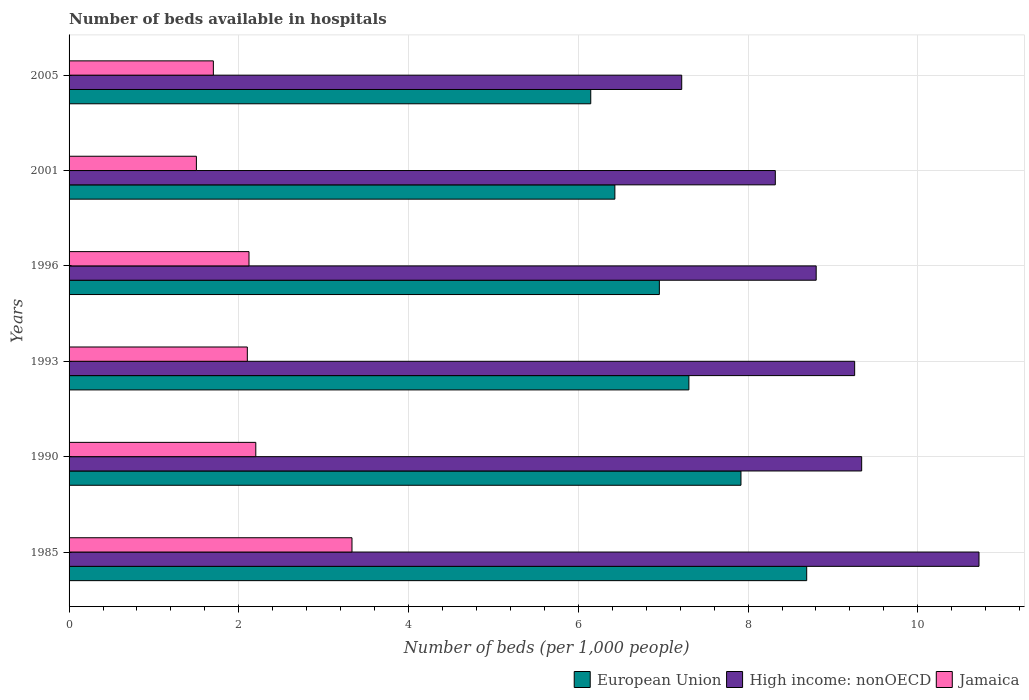Are the number of bars per tick equal to the number of legend labels?
Your answer should be compact. Yes. How many bars are there on the 4th tick from the bottom?
Your response must be concise. 3. What is the label of the 6th group of bars from the top?
Your answer should be very brief. 1985. In how many cases, is the number of bars for a given year not equal to the number of legend labels?
Provide a succinct answer. 0. What is the number of beds in the hospiatls of in European Union in 2005?
Your answer should be compact. 6.15. Across all years, what is the maximum number of beds in the hospiatls of in High income: nonOECD?
Your response must be concise. 10.72. Across all years, what is the minimum number of beds in the hospiatls of in European Union?
Offer a very short reply. 6.15. In which year was the number of beds in the hospiatls of in European Union maximum?
Your answer should be compact. 1985. What is the total number of beds in the hospiatls of in High income: nonOECD in the graph?
Make the answer very short. 53.66. What is the difference between the number of beds in the hospiatls of in Jamaica in 2001 and that in 2005?
Provide a succinct answer. -0.2. What is the difference between the number of beds in the hospiatls of in European Union in 1990 and the number of beds in the hospiatls of in High income: nonOECD in 1996?
Provide a succinct answer. -0.89. What is the average number of beds in the hospiatls of in High income: nonOECD per year?
Keep it short and to the point. 8.94. In the year 1990, what is the difference between the number of beds in the hospiatls of in High income: nonOECD and number of beds in the hospiatls of in Jamaica?
Make the answer very short. 7.14. What is the ratio of the number of beds in the hospiatls of in European Union in 1990 to that in 1996?
Your answer should be very brief. 1.14. Is the difference between the number of beds in the hospiatls of in High income: nonOECD in 1990 and 1993 greater than the difference between the number of beds in the hospiatls of in Jamaica in 1990 and 1993?
Offer a very short reply. No. What is the difference between the highest and the second highest number of beds in the hospiatls of in European Union?
Offer a terse response. 0.77. What is the difference between the highest and the lowest number of beds in the hospiatls of in Jamaica?
Make the answer very short. 1.83. In how many years, is the number of beds in the hospiatls of in Jamaica greater than the average number of beds in the hospiatls of in Jamaica taken over all years?
Your answer should be compact. 2. Is the sum of the number of beds in the hospiatls of in Jamaica in 1996 and 2001 greater than the maximum number of beds in the hospiatls of in European Union across all years?
Your answer should be compact. No. What does the 1st bar from the top in 2001 represents?
Your answer should be compact. Jamaica. What does the 2nd bar from the bottom in 1990 represents?
Offer a terse response. High income: nonOECD. Is it the case that in every year, the sum of the number of beds in the hospiatls of in European Union and number of beds in the hospiatls of in Jamaica is greater than the number of beds in the hospiatls of in High income: nonOECD?
Provide a short and direct response. No. How many years are there in the graph?
Offer a very short reply. 6. What is the difference between two consecutive major ticks on the X-axis?
Ensure brevity in your answer.  2. Does the graph contain any zero values?
Your answer should be very brief. No. Where does the legend appear in the graph?
Your answer should be very brief. Bottom right. How many legend labels are there?
Offer a very short reply. 3. What is the title of the graph?
Offer a terse response. Number of beds available in hospitals. Does "Slovak Republic" appear as one of the legend labels in the graph?
Your answer should be very brief. No. What is the label or title of the X-axis?
Provide a short and direct response. Number of beds (per 1,0 people). What is the Number of beds (per 1,000 people) of European Union in 1985?
Give a very brief answer. 8.69. What is the Number of beds (per 1,000 people) of High income: nonOECD in 1985?
Provide a succinct answer. 10.72. What is the Number of beds (per 1,000 people) in Jamaica in 1985?
Make the answer very short. 3.33. What is the Number of beds (per 1,000 people) in European Union in 1990?
Provide a short and direct response. 7.92. What is the Number of beds (per 1,000 people) in High income: nonOECD in 1990?
Provide a short and direct response. 9.34. What is the Number of beds (per 1,000 people) of Jamaica in 1990?
Ensure brevity in your answer.  2.2. What is the Number of beds (per 1,000 people) of European Union in 1993?
Provide a short and direct response. 7.3. What is the Number of beds (per 1,000 people) in High income: nonOECD in 1993?
Your answer should be very brief. 9.26. What is the Number of beds (per 1,000 people) in Jamaica in 1993?
Your answer should be very brief. 2.1. What is the Number of beds (per 1,000 people) of European Union in 1996?
Keep it short and to the point. 6.95. What is the Number of beds (per 1,000 people) in High income: nonOECD in 1996?
Offer a terse response. 8.8. What is the Number of beds (per 1,000 people) of Jamaica in 1996?
Make the answer very short. 2.12. What is the Number of beds (per 1,000 people) of European Union in 2001?
Provide a short and direct response. 6.43. What is the Number of beds (per 1,000 people) of High income: nonOECD in 2001?
Provide a short and direct response. 8.32. What is the Number of beds (per 1,000 people) in European Union in 2005?
Provide a short and direct response. 6.15. What is the Number of beds (per 1,000 people) of High income: nonOECD in 2005?
Make the answer very short. 7.22. What is the Number of beds (per 1,000 people) in Jamaica in 2005?
Provide a succinct answer. 1.7. Across all years, what is the maximum Number of beds (per 1,000 people) of European Union?
Give a very brief answer. 8.69. Across all years, what is the maximum Number of beds (per 1,000 people) in High income: nonOECD?
Your answer should be very brief. 10.72. Across all years, what is the maximum Number of beds (per 1,000 people) of Jamaica?
Provide a short and direct response. 3.33. Across all years, what is the minimum Number of beds (per 1,000 people) of European Union?
Your response must be concise. 6.15. Across all years, what is the minimum Number of beds (per 1,000 people) of High income: nonOECD?
Your response must be concise. 7.22. Across all years, what is the minimum Number of beds (per 1,000 people) of Jamaica?
Provide a short and direct response. 1.5. What is the total Number of beds (per 1,000 people) of European Union in the graph?
Ensure brevity in your answer.  43.44. What is the total Number of beds (per 1,000 people) in High income: nonOECD in the graph?
Offer a terse response. 53.66. What is the total Number of beds (per 1,000 people) of Jamaica in the graph?
Provide a succinct answer. 12.95. What is the difference between the Number of beds (per 1,000 people) in European Union in 1985 and that in 1990?
Your response must be concise. 0.77. What is the difference between the Number of beds (per 1,000 people) in High income: nonOECD in 1985 and that in 1990?
Your answer should be compact. 1.38. What is the difference between the Number of beds (per 1,000 people) in Jamaica in 1985 and that in 1990?
Offer a terse response. 1.13. What is the difference between the Number of beds (per 1,000 people) of European Union in 1985 and that in 1993?
Keep it short and to the point. 1.39. What is the difference between the Number of beds (per 1,000 people) of High income: nonOECD in 1985 and that in 1993?
Provide a short and direct response. 1.47. What is the difference between the Number of beds (per 1,000 people) of Jamaica in 1985 and that in 1993?
Provide a succinct answer. 1.23. What is the difference between the Number of beds (per 1,000 people) of European Union in 1985 and that in 1996?
Offer a terse response. 1.74. What is the difference between the Number of beds (per 1,000 people) in High income: nonOECD in 1985 and that in 1996?
Your answer should be very brief. 1.92. What is the difference between the Number of beds (per 1,000 people) of Jamaica in 1985 and that in 1996?
Your answer should be very brief. 1.21. What is the difference between the Number of beds (per 1,000 people) in European Union in 1985 and that in 2001?
Make the answer very short. 2.26. What is the difference between the Number of beds (per 1,000 people) of High income: nonOECD in 1985 and that in 2001?
Your answer should be very brief. 2.4. What is the difference between the Number of beds (per 1,000 people) of Jamaica in 1985 and that in 2001?
Your response must be concise. 1.83. What is the difference between the Number of beds (per 1,000 people) in European Union in 1985 and that in 2005?
Your answer should be compact. 2.54. What is the difference between the Number of beds (per 1,000 people) in High income: nonOECD in 1985 and that in 2005?
Your answer should be very brief. 3.5. What is the difference between the Number of beds (per 1,000 people) of Jamaica in 1985 and that in 2005?
Provide a short and direct response. 1.63. What is the difference between the Number of beds (per 1,000 people) of European Union in 1990 and that in 1993?
Provide a succinct answer. 0.61. What is the difference between the Number of beds (per 1,000 people) in High income: nonOECD in 1990 and that in 1993?
Provide a short and direct response. 0.08. What is the difference between the Number of beds (per 1,000 people) in Jamaica in 1990 and that in 1993?
Provide a short and direct response. 0.1. What is the difference between the Number of beds (per 1,000 people) in European Union in 1990 and that in 1996?
Give a very brief answer. 0.96. What is the difference between the Number of beds (per 1,000 people) in High income: nonOECD in 1990 and that in 1996?
Your response must be concise. 0.54. What is the difference between the Number of beds (per 1,000 people) in Jamaica in 1990 and that in 1996?
Offer a terse response. 0.08. What is the difference between the Number of beds (per 1,000 people) of European Union in 1990 and that in 2001?
Ensure brevity in your answer.  1.49. What is the difference between the Number of beds (per 1,000 people) of High income: nonOECD in 1990 and that in 2001?
Ensure brevity in your answer.  1.02. What is the difference between the Number of beds (per 1,000 people) in Jamaica in 1990 and that in 2001?
Offer a terse response. 0.7. What is the difference between the Number of beds (per 1,000 people) of European Union in 1990 and that in 2005?
Give a very brief answer. 1.77. What is the difference between the Number of beds (per 1,000 people) of High income: nonOECD in 1990 and that in 2005?
Ensure brevity in your answer.  2.12. What is the difference between the Number of beds (per 1,000 people) of European Union in 1993 and that in 1996?
Provide a succinct answer. 0.35. What is the difference between the Number of beds (per 1,000 people) in High income: nonOECD in 1993 and that in 1996?
Provide a short and direct response. 0.45. What is the difference between the Number of beds (per 1,000 people) in Jamaica in 1993 and that in 1996?
Your answer should be very brief. -0.02. What is the difference between the Number of beds (per 1,000 people) in European Union in 1993 and that in 2001?
Offer a very short reply. 0.87. What is the difference between the Number of beds (per 1,000 people) of High income: nonOECD in 1993 and that in 2001?
Give a very brief answer. 0.93. What is the difference between the Number of beds (per 1,000 people) of Jamaica in 1993 and that in 2001?
Offer a terse response. 0.6. What is the difference between the Number of beds (per 1,000 people) of European Union in 1993 and that in 2005?
Provide a short and direct response. 1.16. What is the difference between the Number of beds (per 1,000 people) of High income: nonOECD in 1993 and that in 2005?
Your response must be concise. 2.04. What is the difference between the Number of beds (per 1,000 people) in Jamaica in 1993 and that in 2005?
Offer a very short reply. 0.4. What is the difference between the Number of beds (per 1,000 people) of European Union in 1996 and that in 2001?
Offer a very short reply. 0.52. What is the difference between the Number of beds (per 1,000 people) of High income: nonOECD in 1996 and that in 2001?
Offer a very short reply. 0.48. What is the difference between the Number of beds (per 1,000 people) in Jamaica in 1996 and that in 2001?
Provide a succinct answer. 0.62. What is the difference between the Number of beds (per 1,000 people) in European Union in 1996 and that in 2005?
Offer a very short reply. 0.81. What is the difference between the Number of beds (per 1,000 people) in High income: nonOECD in 1996 and that in 2005?
Give a very brief answer. 1.58. What is the difference between the Number of beds (per 1,000 people) in Jamaica in 1996 and that in 2005?
Offer a terse response. 0.42. What is the difference between the Number of beds (per 1,000 people) of European Union in 2001 and that in 2005?
Provide a succinct answer. 0.28. What is the difference between the Number of beds (per 1,000 people) in High income: nonOECD in 2001 and that in 2005?
Give a very brief answer. 1.1. What is the difference between the Number of beds (per 1,000 people) of Jamaica in 2001 and that in 2005?
Offer a very short reply. -0.2. What is the difference between the Number of beds (per 1,000 people) of European Union in 1985 and the Number of beds (per 1,000 people) of High income: nonOECD in 1990?
Your response must be concise. -0.65. What is the difference between the Number of beds (per 1,000 people) of European Union in 1985 and the Number of beds (per 1,000 people) of Jamaica in 1990?
Provide a short and direct response. 6.49. What is the difference between the Number of beds (per 1,000 people) in High income: nonOECD in 1985 and the Number of beds (per 1,000 people) in Jamaica in 1990?
Keep it short and to the point. 8.52. What is the difference between the Number of beds (per 1,000 people) in European Union in 1985 and the Number of beds (per 1,000 people) in High income: nonOECD in 1993?
Keep it short and to the point. -0.56. What is the difference between the Number of beds (per 1,000 people) in European Union in 1985 and the Number of beds (per 1,000 people) in Jamaica in 1993?
Your answer should be compact. 6.59. What is the difference between the Number of beds (per 1,000 people) in High income: nonOECD in 1985 and the Number of beds (per 1,000 people) in Jamaica in 1993?
Your answer should be compact. 8.62. What is the difference between the Number of beds (per 1,000 people) in European Union in 1985 and the Number of beds (per 1,000 people) in High income: nonOECD in 1996?
Keep it short and to the point. -0.11. What is the difference between the Number of beds (per 1,000 people) of European Union in 1985 and the Number of beds (per 1,000 people) of Jamaica in 1996?
Offer a terse response. 6.57. What is the difference between the Number of beds (per 1,000 people) in High income: nonOECD in 1985 and the Number of beds (per 1,000 people) in Jamaica in 1996?
Offer a terse response. 8.6. What is the difference between the Number of beds (per 1,000 people) in European Union in 1985 and the Number of beds (per 1,000 people) in High income: nonOECD in 2001?
Your response must be concise. 0.37. What is the difference between the Number of beds (per 1,000 people) in European Union in 1985 and the Number of beds (per 1,000 people) in Jamaica in 2001?
Make the answer very short. 7.19. What is the difference between the Number of beds (per 1,000 people) of High income: nonOECD in 1985 and the Number of beds (per 1,000 people) of Jamaica in 2001?
Give a very brief answer. 9.22. What is the difference between the Number of beds (per 1,000 people) of European Union in 1985 and the Number of beds (per 1,000 people) of High income: nonOECD in 2005?
Give a very brief answer. 1.47. What is the difference between the Number of beds (per 1,000 people) in European Union in 1985 and the Number of beds (per 1,000 people) in Jamaica in 2005?
Make the answer very short. 6.99. What is the difference between the Number of beds (per 1,000 people) of High income: nonOECD in 1985 and the Number of beds (per 1,000 people) of Jamaica in 2005?
Your answer should be compact. 9.02. What is the difference between the Number of beds (per 1,000 people) in European Union in 1990 and the Number of beds (per 1,000 people) in High income: nonOECD in 1993?
Provide a short and direct response. -1.34. What is the difference between the Number of beds (per 1,000 people) of European Union in 1990 and the Number of beds (per 1,000 people) of Jamaica in 1993?
Your answer should be compact. 5.82. What is the difference between the Number of beds (per 1,000 people) of High income: nonOECD in 1990 and the Number of beds (per 1,000 people) of Jamaica in 1993?
Offer a terse response. 7.24. What is the difference between the Number of beds (per 1,000 people) in European Union in 1990 and the Number of beds (per 1,000 people) in High income: nonOECD in 1996?
Offer a very short reply. -0.89. What is the difference between the Number of beds (per 1,000 people) of European Union in 1990 and the Number of beds (per 1,000 people) of Jamaica in 1996?
Your answer should be compact. 5.8. What is the difference between the Number of beds (per 1,000 people) in High income: nonOECD in 1990 and the Number of beds (per 1,000 people) in Jamaica in 1996?
Give a very brief answer. 7.22. What is the difference between the Number of beds (per 1,000 people) in European Union in 1990 and the Number of beds (per 1,000 people) in High income: nonOECD in 2001?
Your answer should be very brief. -0.4. What is the difference between the Number of beds (per 1,000 people) of European Union in 1990 and the Number of beds (per 1,000 people) of Jamaica in 2001?
Provide a succinct answer. 6.42. What is the difference between the Number of beds (per 1,000 people) of High income: nonOECD in 1990 and the Number of beds (per 1,000 people) of Jamaica in 2001?
Give a very brief answer. 7.84. What is the difference between the Number of beds (per 1,000 people) of European Union in 1990 and the Number of beds (per 1,000 people) of High income: nonOECD in 2005?
Offer a terse response. 0.7. What is the difference between the Number of beds (per 1,000 people) in European Union in 1990 and the Number of beds (per 1,000 people) in Jamaica in 2005?
Ensure brevity in your answer.  6.22. What is the difference between the Number of beds (per 1,000 people) in High income: nonOECD in 1990 and the Number of beds (per 1,000 people) in Jamaica in 2005?
Provide a succinct answer. 7.64. What is the difference between the Number of beds (per 1,000 people) of European Union in 1993 and the Number of beds (per 1,000 people) of High income: nonOECD in 1996?
Your answer should be very brief. -1.5. What is the difference between the Number of beds (per 1,000 people) of European Union in 1993 and the Number of beds (per 1,000 people) of Jamaica in 1996?
Offer a very short reply. 5.18. What is the difference between the Number of beds (per 1,000 people) in High income: nonOECD in 1993 and the Number of beds (per 1,000 people) in Jamaica in 1996?
Keep it short and to the point. 7.14. What is the difference between the Number of beds (per 1,000 people) of European Union in 1993 and the Number of beds (per 1,000 people) of High income: nonOECD in 2001?
Your response must be concise. -1.02. What is the difference between the Number of beds (per 1,000 people) of European Union in 1993 and the Number of beds (per 1,000 people) of Jamaica in 2001?
Your response must be concise. 5.8. What is the difference between the Number of beds (per 1,000 people) in High income: nonOECD in 1993 and the Number of beds (per 1,000 people) in Jamaica in 2001?
Your response must be concise. 7.76. What is the difference between the Number of beds (per 1,000 people) of European Union in 1993 and the Number of beds (per 1,000 people) of High income: nonOECD in 2005?
Your answer should be very brief. 0.08. What is the difference between the Number of beds (per 1,000 people) in European Union in 1993 and the Number of beds (per 1,000 people) in Jamaica in 2005?
Give a very brief answer. 5.6. What is the difference between the Number of beds (per 1,000 people) in High income: nonOECD in 1993 and the Number of beds (per 1,000 people) in Jamaica in 2005?
Offer a very short reply. 7.56. What is the difference between the Number of beds (per 1,000 people) of European Union in 1996 and the Number of beds (per 1,000 people) of High income: nonOECD in 2001?
Make the answer very short. -1.37. What is the difference between the Number of beds (per 1,000 people) in European Union in 1996 and the Number of beds (per 1,000 people) in Jamaica in 2001?
Give a very brief answer. 5.45. What is the difference between the Number of beds (per 1,000 people) of High income: nonOECD in 1996 and the Number of beds (per 1,000 people) of Jamaica in 2001?
Ensure brevity in your answer.  7.3. What is the difference between the Number of beds (per 1,000 people) of European Union in 1996 and the Number of beds (per 1,000 people) of High income: nonOECD in 2005?
Ensure brevity in your answer.  -0.26. What is the difference between the Number of beds (per 1,000 people) of European Union in 1996 and the Number of beds (per 1,000 people) of Jamaica in 2005?
Your response must be concise. 5.25. What is the difference between the Number of beds (per 1,000 people) in High income: nonOECD in 1996 and the Number of beds (per 1,000 people) in Jamaica in 2005?
Offer a terse response. 7.1. What is the difference between the Number of beds (per 1,000 people) of European Union in 2001 and the Number of beds (per 1,000 people) of High income: nonOECD in 2005?
Your response must be concise. -0.79. What is the difference between the Number of beds (per 1,000 people) of European Union in 2001 and the Number of beds (per 1,000 people) of Jamaica in 2005?
Make the answer very short. 4.73. What is the difference between the Number of beds (per 1,000 people) of High income: nonOECD in 2001 and the Number of beds (per 1,000 people) of Jamaica in 2005?
Provide a succinct answer. 6.62. What is the average Number of beds (per 1,000 people) in European Union per year?
Offer a very short reply. 7.24. What is the average Number of beds (per 1,000 people) in High income: nonOECD per year?
Provide a succinct answer. 8.94. What is the average Number of beds (per 1,000 people) of Jamaica per year?
Offer a very short reply. 2.16. In the year 1985, what is the difference between the Number of beds (per 1,000 people) in European Union and Number of beds (per 1,000 people) in High income: nonOECD?
Ensure brevity in your answer.  -2.03. In the year 1985, what is the difference between the Number of beds (per 1,000 people) of European Union and Number of beds (per 1,000 people) of Jamaica?
Offer a very short reply. 5.36. In the year 1985, what is the difference between the Number of beds (per 1,000 people) of High income: nonOECD and Number of beds (per 1,000 people) of Jamaica?
Make the answer very short. 7.39. In the year 1990, what is the difference between the Number of beds (per 1,000 people) of European Union and Number of beds (per 1,000 people) of High income: nonOECD?
Keep it short and to the point. -1.42. In the year 1990, what is the difference between the Number of beds (per 1,000 people) in European Union and Number of beds (per 1,000 people) in Jamaica?
Offer a terse response. 5.72. In the year 1990, what is the difference between the Number of beds (per 1,000 people) of High income: nonOECD and Number of beds (per 1,000 people) of Jamaica?
Ensure brevity in your answer.  7.14. In the year 1993, what is the difference between the Number of beds (per 1,000 people) in European Union and Number of beds (per 1,000 people) in High income: nonOECD?
Your answer should be compact. -1.95. In the year 1993, what is the difference between the Number of beds (per 1,000 people) of European Union and Number of beds (per 1,000 people) of Jamaica?
Your answer should be very brief. 5.2. In the year 1993, what is the difference between the Number of beds (per 1,000 people) in High income: nonOECD and Number of beds (per 1,000 people) in Jamaica?
Give a very brief answer. 7.16. In the year 1996, what is the difference between the Number of beds (per 1,000 people) in European Union and Number of beds (per 1,000 people) in High income: nonOECD?
Your answer should be very brief. -1.85. In the year 1996, what is the difference between the Number of beds (per 1,000 people) of European Union and Number of beds (per 1,000 people) of Jamaica?
Give a very brief answer. 4.83. In the year 1996, what is the difference between the Number of beds (per 1,000 people) of High income: nonOECD and Number of beds (per 1,000 people) of Jamaica?
Provide a short and direct response. 6.68. In the year 2001, what is the difference between the Number of beds (per 1,000 people) of European Union and Number of beds (per 1,000 people) of High income: nonOECD?
Keep it short and to the point. -1.89. In the year 2001, what is the difference between the Number of beds (per 1,000 people) of European Union and Number of beds (per 1,000 people) of Jamaica?
Give a very brief answer. 4.93. In the year 2001, what is the difference between the Number of beds (per 1,000 people) of High income: nonOECD and Number of beds (per 1,000 people) of Jamaica?
Give a very brief answer. 6.82. In the year 2005, what is the difference between the Number of beds (per 1,000 people) of European Union and Number of beds (per 1,000 people) of High income: nonOECD?
Make the answer very short. -1.07. In the year 2005, what is the difference between the Number of beds (per 1,000 people) of European Union and Number of beds (per 1,000 people) of Jamaica?
Your answer should be compact. 4.45. In the year 2005, what is the difference between the Number of beds (per 1,000 people) of High income: nonOECD and Number of beds (per 1,000 people) of Jamaica?
Give a very brief answer. 5.52. What is the ratio of the Number of beds (per 1,000 people) in European Union in 1985 to that in 1990?
Make the answer very short. 1.1. What is the ratio of the Number of beds (per 1,000 people) of High income: nonOECD in 1985 to that in 1990?
Give a very brief answer. 1.15. What is the ratio of the Number of beds (per 1,000 people) in Jamaica in 1985 to that in 1990?
Make the answer very short. 1.52. What is the ratio of the Number of beds (per 1,000 people) of European Union in 1985 to that in 1993?
Your response must be concise. 1.19. What is the ratio of the Number of beds (per 1,000 people) in High income: nonOECD in 1985 to that in 1993?
Your answer should be very brief. 1.16. What is the ratio of the Number of beds (per 1,000 people) of Jamaica in 1985 to that in 1993?
Provide a succinct answer. 1.59. What is the ratio of the Number of beds (per 1,000 people) of European Union in 1985 to that in 1996?
Ensure brevity in your answer.  1.25. What is the ratio of the Number of beds (per 1,000 people) in High income: nonOECD in 1985 to that in 1996?
Offer a very short reply. 1.22. What is the ratio of the Number of beds (per 1,000 people) in Jamaica in 1985 to that in 1996?
Provide a short and direct response. 1.57. What is the ratio of the Number of beds (per 1,000 people) of European Union in 1985 to that in 2001?
Your answer should be very brief. 1.35. What is the ratio of the Number of beds (per 1,000 people) of High income: nonOECD in 1985 to that in 2001?
Keep it short and to the point. 1.29. What is the ratio of the Number of beds (per 1,000 people) in Jamaica in 1985 to that in 2001?
Offer a very short reply. 2.22. What is the ratio of the Number of beds (per 1,000 people) in European Union in 1985 to that in 2005?
Keep it short and to the point. 1.41. What is the ratio of the Number of beds (per 1,000 people) of High income: nonOECD in 1985 to that in 2005?
Your answer should be very brief. 1.49. What is the ratio of the Number of beds (per 1,000 people) of Jamaica in 1985 to that in 2005?
Make the answer very short. 1.96. What is the ratio of the Number of beds (per 1,000 people) in European Union in 1990 to that in 1993?
Ensure brevity in your answer.  1.08. What is the ratio of the Number of beds (per 1,000 people) in High income: nonOECD in 1990 to that in 1993?
Offer a very short reply. 1.01. What is the ratio of the Number of beds (per 1,000 people) in Jamaica in 1990 to that in 1993?
Give a very brief answer. 1.05. What is the ratio of the Number of beds (per 1,000 people) in European Union in 1990 to that in 1996?
Offer a very short reply. 1.14. What is the ratio of the Number of beds (per 1,000 people) of High income: nonOECD in 1990 to that in 1996?
Offer a very short reply. 1.06. What is the ratio of the Number of beds (per 1,000 people) of Jamaica in 1990 to that in 1996?
Your answer should be very brief. 1.04. What is the ratio of the Number of beds (per 1,000 people) in European Union in 1990 to that in 2001?
Your answer should be compact. 1.23. What is the ratio of the Number of beds (per 1,000 people) of High income: nonOECD in 1990 to that in 2001?
Offer a very short reply. 1.12. What is the ratio of the Number of beds (per 1,000 people) of Jamaica in 1990 to that in 2001?
Make the answer very short. 1.47. What is the ratio of the Number of beds (per 1,000 people) in European Union in 1990 to that in 2005?
Your response must be concise. 1.29. What is the ratio of the Number of beds (per 1,000 people) of High income: nonOECD in 1990 to that in 2005?
Keep it short and to the point. 1.29. What is the ratio of the Number of beds (per 1,000 people) of Jamaica in 1990 to that in 2005?
Ensure brevity in your answer.  1.29. What is the ratio of the Number of beds (per 1,000 people) in High income: nonOECD in 1993 to that in 1996?
Provide a succinct answer. 1.05. What is the ratio of the Number of beds (per 1,000 people) of Jamaica in 1993 to that in 1996?
Ensure brevity in your answer.  0.99. What is the ratio of the Number of beds (per 1,000 people) in European Union in 1993 to that in 2001?
Offer a very short reply. 1.14. What is the ratio of the Number of beds (per 1,000 people) of High income: nonOECD in 1993 to that in 2001?
Offer a terse response. 1.11. What is the ratio of the Number of beds (per 1,000 people) in Jamaica in 1993 to that in 2001?
Your answer should be compact. 1.4. What is the ratio of the Number of beds (per 1,000 people) of European Union in 1993 to that in 2005?
Offer a terse response. 1.19. What is the ratio of the Number of beds (per 1,000 people) of High income: nonOECD in 1993 to that in 2005?
Give a very brief answer. 1.28. What is the ratio of the Number of beds (per 1,000 people) in Jamaica in 1993 to that in 2005?
Give a very brief answer. 1.24. What is the ratio of the Number of beds (per 1,000 people) in European Union in 1996 to that in 2001?
Offer a very short reply. 1.08. What is the ratio of the Number of beds (per 1,000 people) of High income: nonOECD in 1996 to that in 2001?
Give a very brief answer. 1.06. What is the ratio of the Number of beds (per 1,000 people) in Jamaica in 1996 to that in 2001?
Offer a very short reply. 1.41. What is the ratio of the Number of beds (per 1,000 people) in European Union in 1996 to that in 2005?
Your answer should be compact. 1.13. What is the ratio of the Number of beds (per 1,000 people) of High income: nonOECD in 1996 to that in 2005?
Provide a succinct answer. 1.22. What is the ratio of the Number of beds (per 1,000 people) of Jamaica in 1996 to that in 2005?
Your response must be concise. 1.25. What is the ratio of the Number of beds (per 1,000 people) in European Union in 2001 to that in 2005?
Provide a short and direct response. 1.05. What is the ratio of the Number of beds (per 1,000 people) of High income: nonOECD in 2001 to that in 2005?
Your response must be concise. 1.15. What is the ratio of the Number of beds (per 1,000 people) of Jamaica in 2001 to that in 2005?
Offer a terse response. 0.88. What is the difference between the highest and the second highest Number of beds (per 1,000 people) in European Union?
Provide a short and direct response. 0.77. What is the difference between the highest and the second highest Number of beds (per 1,000 people) of High income: nonOECD?
Your answer should be very brief. 1.38. What is the difference between the highest and the second highest Number of beds (per 1,000 people) in Jamaica?
Provide a succinct answer. 1.13. What is the difference between the highest and the lowest Number of beds (per 1,000 people) of European Union?
Offer a very short reply. 2.54. What is the difference between the highest and the lowest Number of beds (per 1,000 people) of High income: nonOECD?
Offer a terse response. 3.5. What is the difference between the highest and the lowest Number of beds (per 1,000 people) in Jamaica?
Offer a terse response. 1.83. 